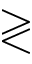<formula> <loc_0><loc_0><loc_500><loc_500>\gtrless</formula> 